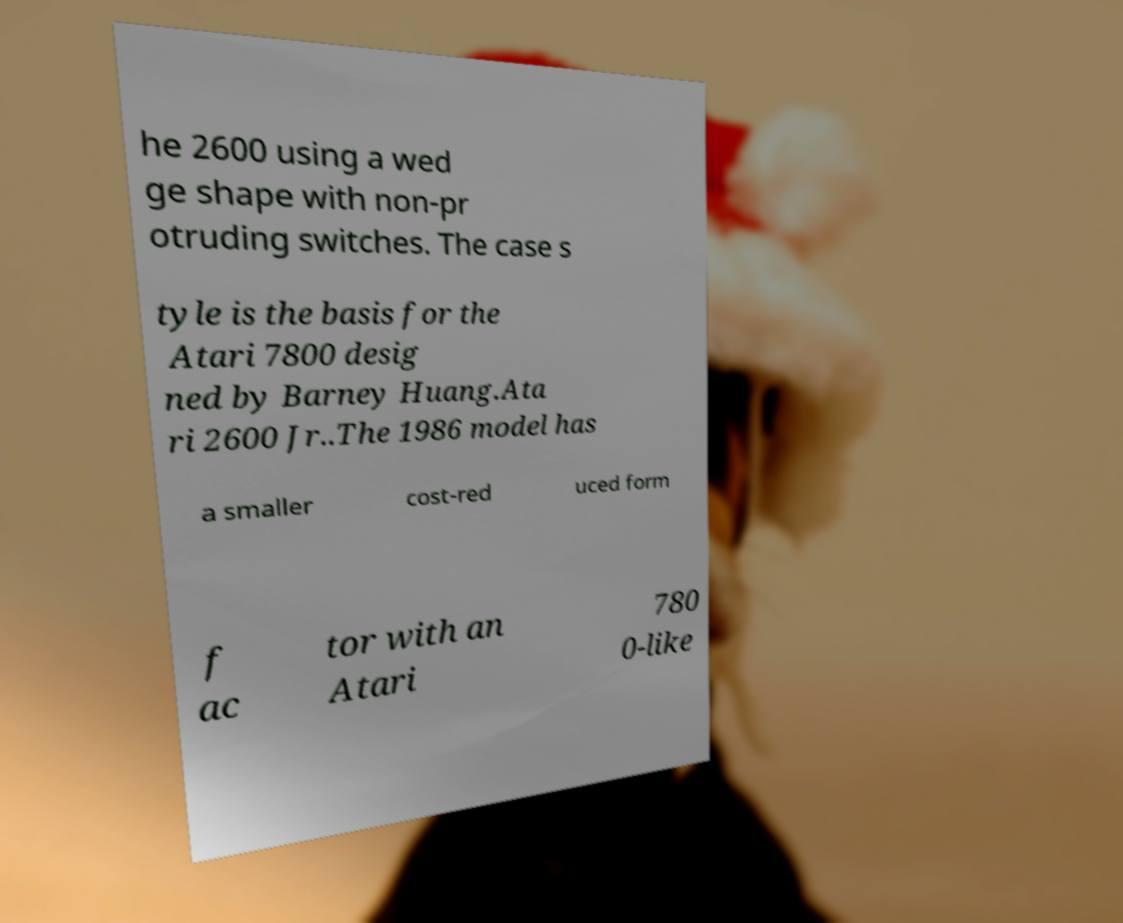Can you read and provide the text displayed in the image?This photo seems to have some interesting text. Can you extract and type it out for me? he 2600 using a wed ge shape with non-pr otruding switches. The case s tyle is the basis for the Atari 7800 desig ned by Barney Huang.Ata ri 2600 Jr..The 1986 model has a smaller cost-red uced form f ac tor with an Atari 780 0-like 